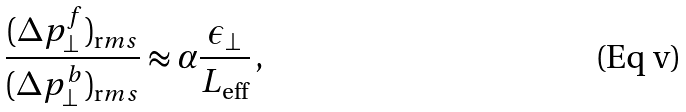<formula> <loc_0><loc_0><loc_500><loc_500>\frac { ( \Delta p ^ { f } _ { \perp } ) _ { \text  rms}}{(\Delta p^{b}_{\perp})_{\text   rms}} \approx \alpha \frac{\epsilon_{\perp}}{L_{\text {eff} } } \, ,</formula> 